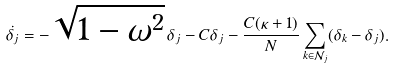<formula> <loc_0><loc_0><loc_500><loc_500>\dot { \delta _ { j } } = - \sqrt { 1 - \omega ^ { 2 } } \, \delta _ { j } - C \delta _ { j } - \frac { C ( \kappa + 1 ) } { N } \sum _ { k \in \mathcal { N } _ { j } } ( \delta _ { k } - \delta _ { j } ) .</formula> 